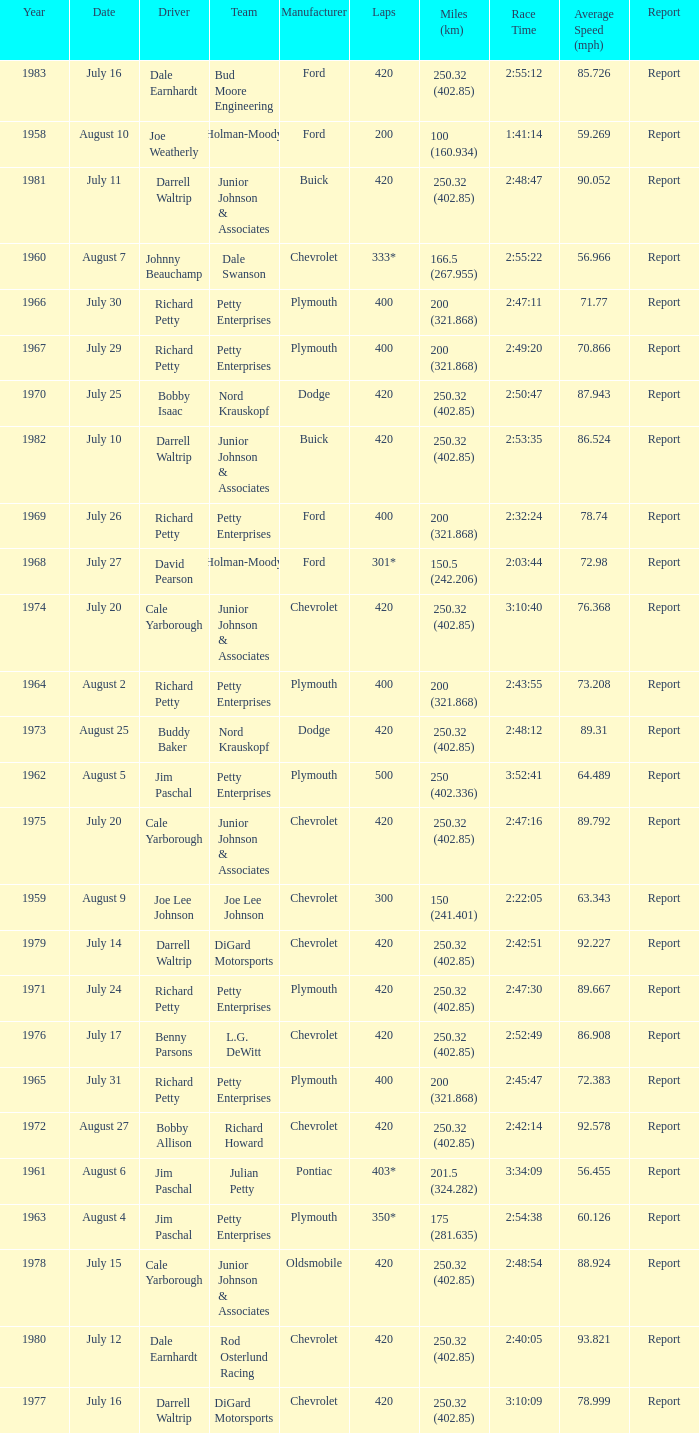What date was the race in 1968 run on? July 27. 